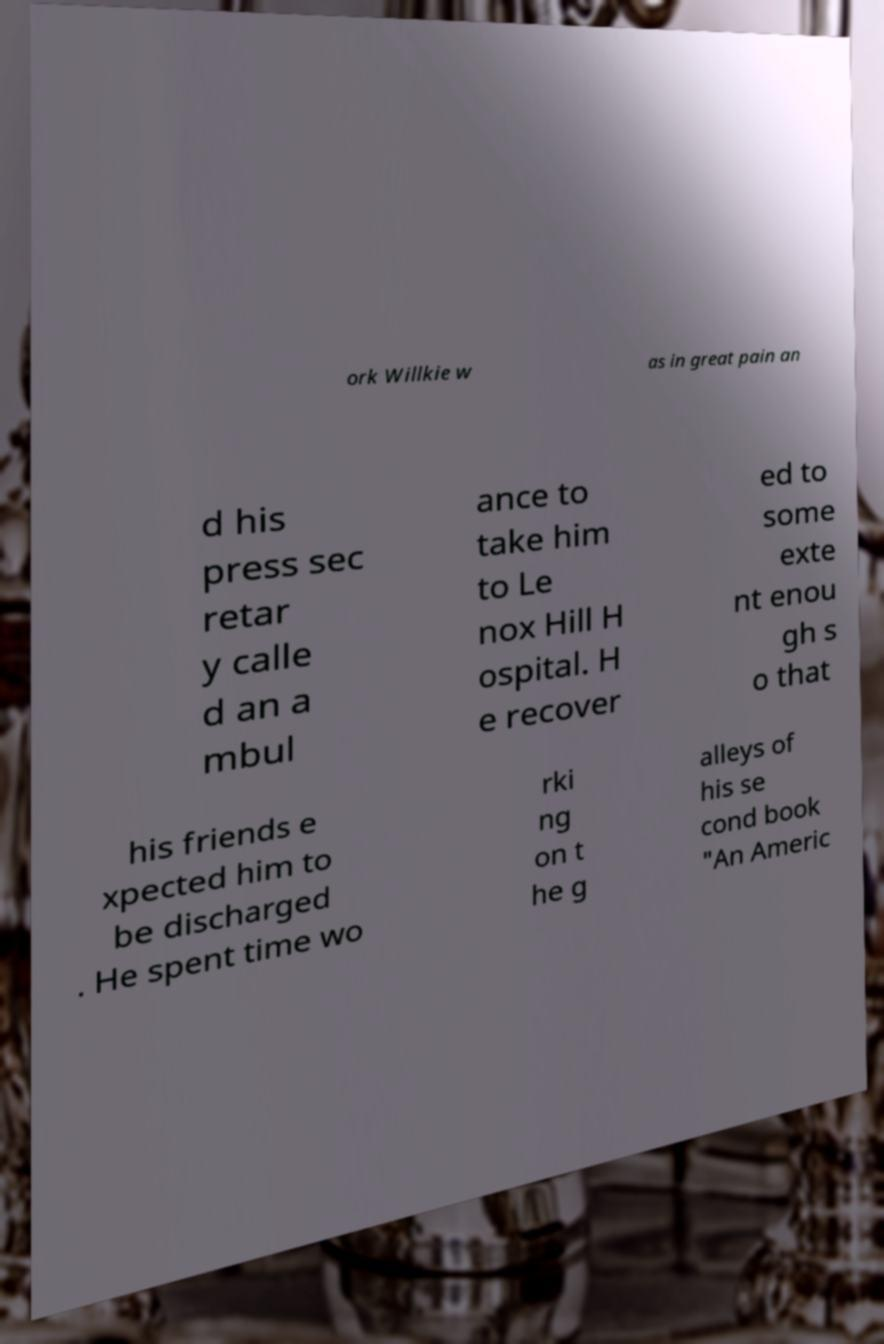Please read and relay the text visible in this image. What does it say? ork Willkie w as in great pain an d his press sec retar y calle d an a mbul ance to take him to Le nox Hill H ospital. H e recover ed to some exte nt enou gh s o that his friends e xpected him to be discharged . He spent time wo rki ng on t he g alleys of his se cond book "An Americ 